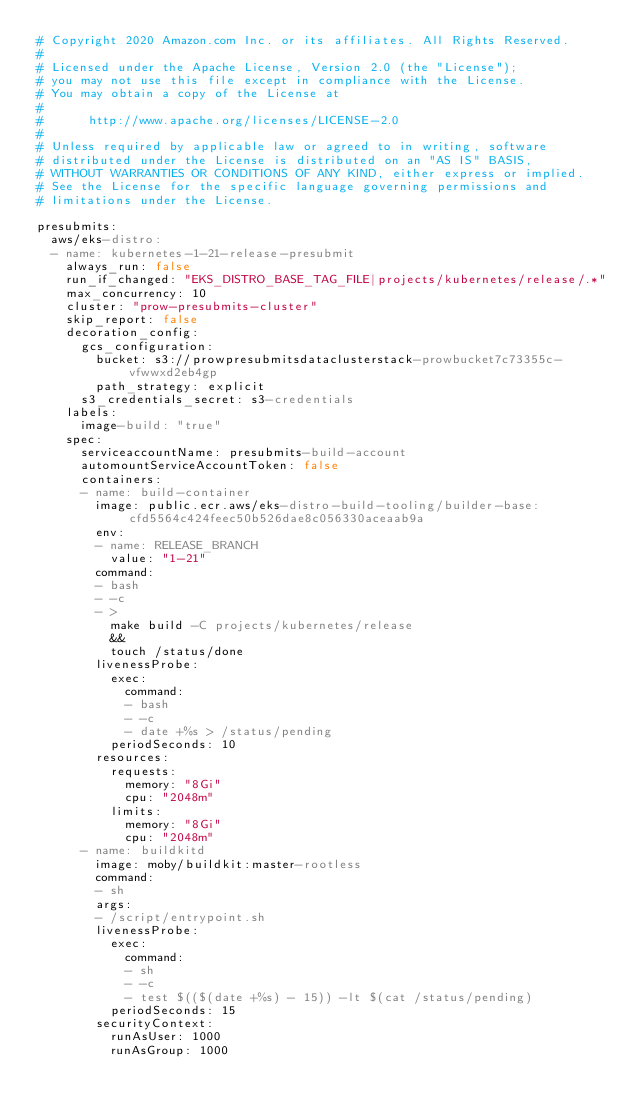Convert code to text. <code><loc_0><loc_0><loc_500><loc_500><_YAML_># Copyright 2020 Amazon.com Inc. or its affiliates. All Rights Reserved.
#
# Licensed under the Apache License, Version 2.0 (the "License");
# you may not use this file except in compliance with the License.
# You may obtain a copy of the License at
#
#      http://www.apache.org/licenses/LICENSE-2.0
#
# Unless required by applicable law or agreed to in writing, software
# distributed under the License is distributed on an "AS IS" BASIS,
# WITHOUT WARRANTIES OR CONDITIONS OF ANY KIND, either express or implied.
# See the License for the specific language governing permissions and
# limitations under the License.

presubmits:
  aws/eks-distro:
  - name: kubernetes-1-21-release-presubmit
    always_run: false
    run_if_changed: "EKS_DISTRO_BASE_TAG_FILE|projects/kubernetes/release/.*"
    max_concurrency: 10
    cluster: "prow-presubmits-cluster"
    skip_report: false
    decoration_config:
      gcs_configuration:
        bucket: s3://prowpresubmitsdataclusterstack-prowbucket7c73355c-vfwwxd2eb4gp
        path_strategy: explicit
      s3_credentials_secret: s3-credentials
    labels:
      image-build: "true"
    spec:
      serviceaccountName: presubmits-build-account
      automountServiceAccountToken: false
      containers:
      - name: build-container
        image: public.ecr.aws/eks-distro-build-tooling/builder-base:cfd5564c424feec50b526dae8c056330aceaab9a
        env:
        - name: RELEASE_BRANCH
          value: "1-21"
        command:
        - bash
        - -c
        - >
          make build -C projects/kubernetes/release
          &&
          touch /status/done
        livenessProbe:
          exec:
            command:
            - bash
            - -c
            - date +%s > /status/pending
          periodSeconds: 10
        resources:
          requests:
            memory: "8Gi"
            cpu: "2048m"
          limits:
            memory: "8Gi"
            cpu: "2048m"
      - name: buildkitd
        image: moby/buildkit:master-rootless
        command:
        - sh
        args:
        - /script/entrypoint.sh
        livenessProbe:
          exec:
            command:
            - sh
            - -c
            - test $(($(date +%s) - 15)) -lt $(cat /status/pending)
          periodSeconds: 15
        securityContext:
          runAsUser: 1000
          runAsGroup: 1000
</code> 